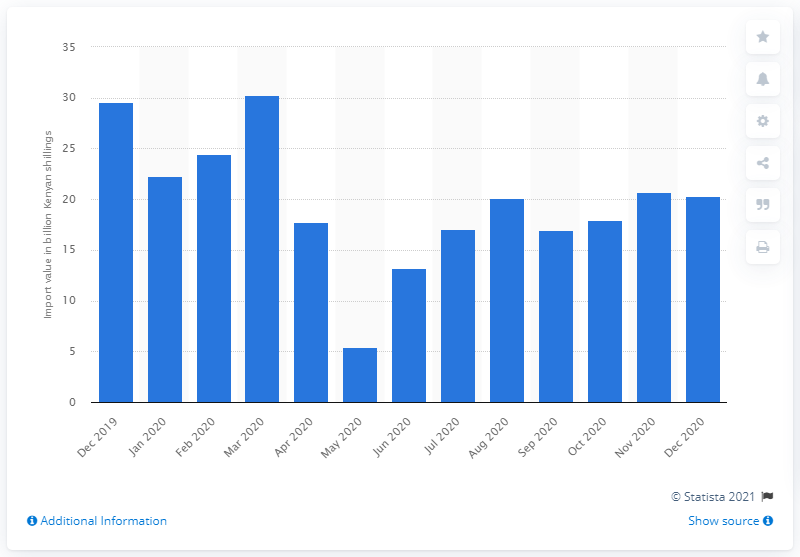Mention a couple of crucial points in this snapshot. In December 2020, the import value of fuel and lubricants to Kenya was 20.3 million dollars. 